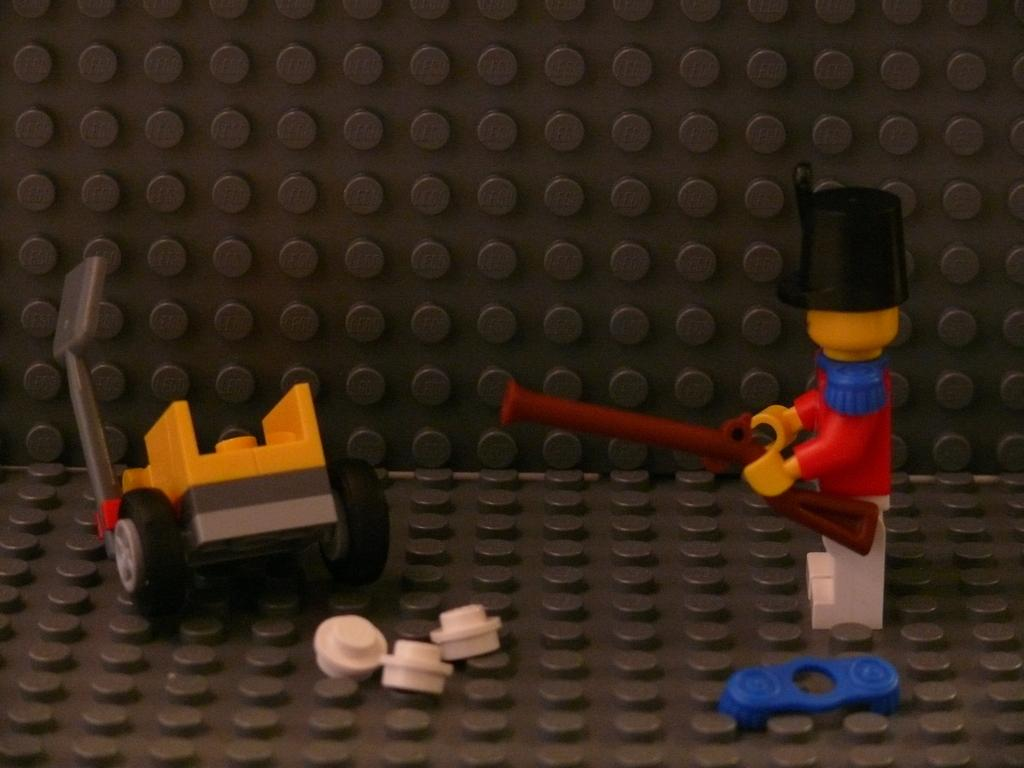What type of objects can be seen in the image? There are colorful toys and building blocks in the image. Can you describe the toys in more detail? The toys are colorful, but the specific types of toys cannot be determined from the image. What can be done with the building blocks in the image? The building blocks can be used for stacking, building, or other creative activities. Can you see a donkey playing with the building blocks in the image? No, there is no donkey present in the image. 